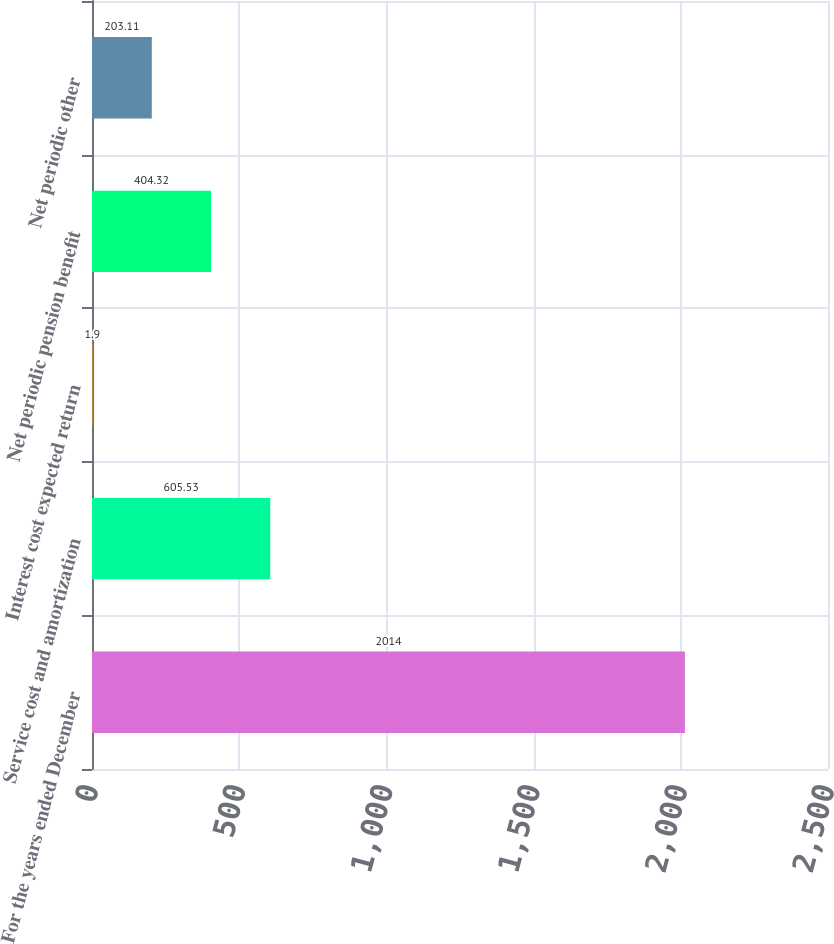<chart> <loc_0><loc_0><loc_500><loc_500><bar_chart><fcel>For the years ended December<fcel>Service cost and amortization<fcel>Interest cost expected return<fcel>Net periodic pension benefit<fcel>Net periodic other<nl><fcel>2014<fcel>605.53<fcel>1.9<fcel>404.32<fcel>203.11<nl></chart> 